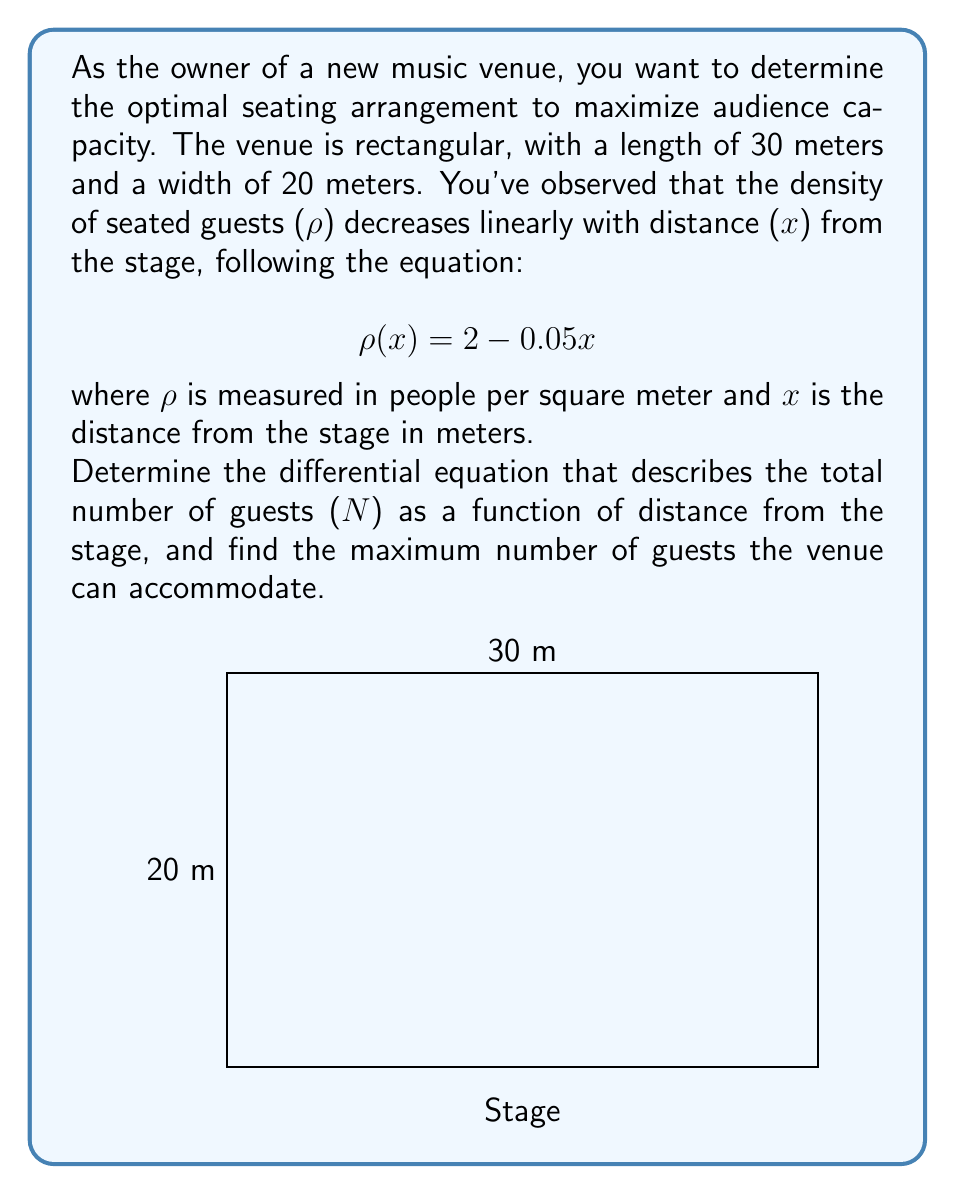Can you solve this math problem? Let's approach this problem step-by-step:

1) First, we need to set up the differential equation. The number of guests in a small strip dx at a distance x from the stage is:

   $$dN = \rho(x) \cdot 20 \cdot dx$$

   Here, 20 is the width of the venue in meters.

2) Substituting the given density function:

   $$dN = (2 - 0.05x) \cdot 20 \cdot dx$$

3) This gives us the differential equation:

   $$\frac{dN}{dx} = 40 - x$$

4) To find the total number of guests, we need to integrate this equation from 0 to 30 (the length of the venue):

   $$N = \int_0^{30} (40 - x) dx$$

5) Solving the integral:

   $$N = [40x - \frac{1}{2}x^2]_0^{30}$$
   $$N = (1200 - 450) - (0 - 0) = 750$$

Therefore, the maximum number of guests the venue can accommodate is 750.
Answer: 750 guests 